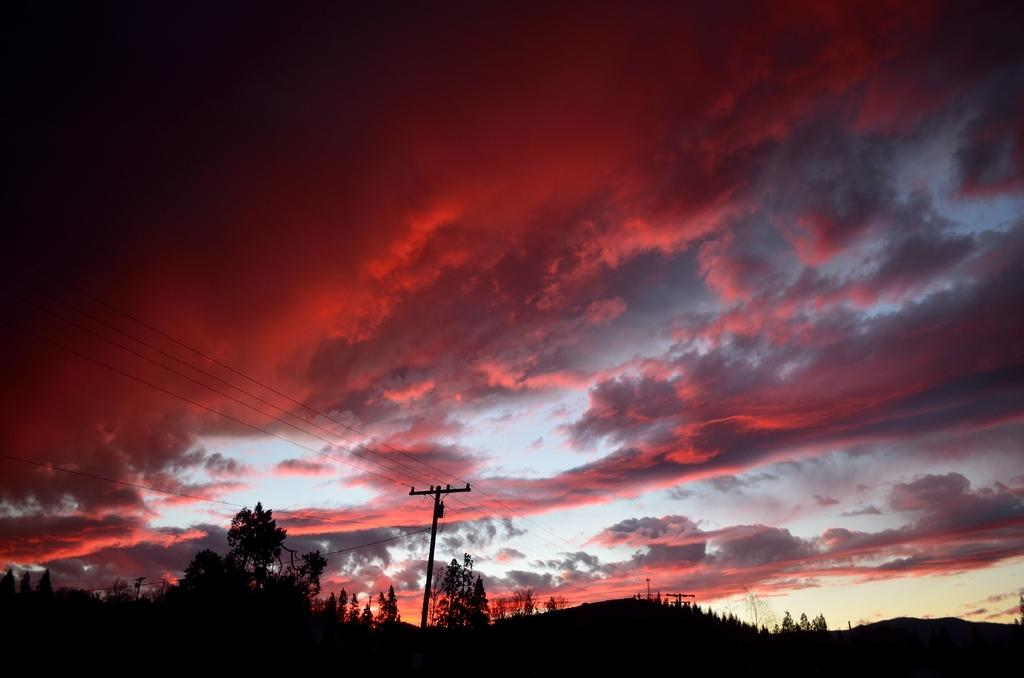What can be seen in the sky in the image? The sky with clouds is visible in the image. What structures are present in the image? Electric poles are visible in the image. What is connected to the electric poles? Electric cables are present in the image. What type of natural elements can be seen in the image? Trees and hills are visible in the image. What type of sugar is being used to sweeten the hills in the image? There is no sugar present in the image, and the hills are not being sweetened. 